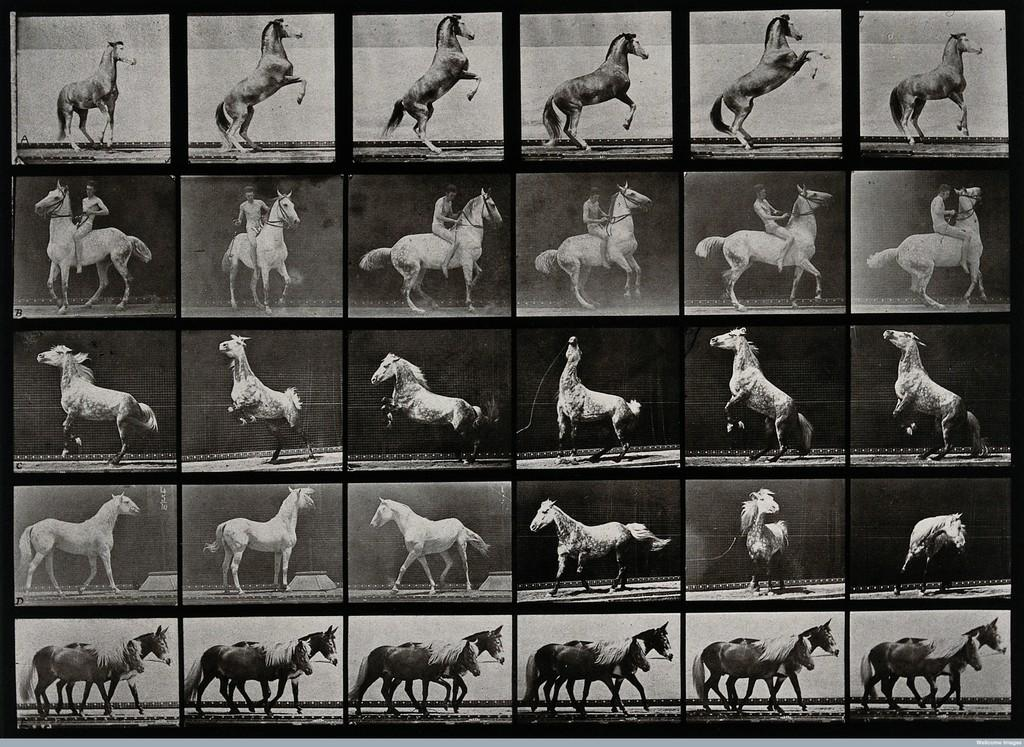What type of image is being described? The image is a collage of different pictures. Are there any specific subjects or themes in the collage? Yes, some of the pictures contain horses. Can you describe the interaction between people and horses in the collage? In some pictures, there is a person riding a horse. What type of notebook is visible in the image? There is no notebook present in the image. Can you describe the downtown area in the image? The image does not depict a downtown area; it is a collage of different pictures, some of which contain horses. 